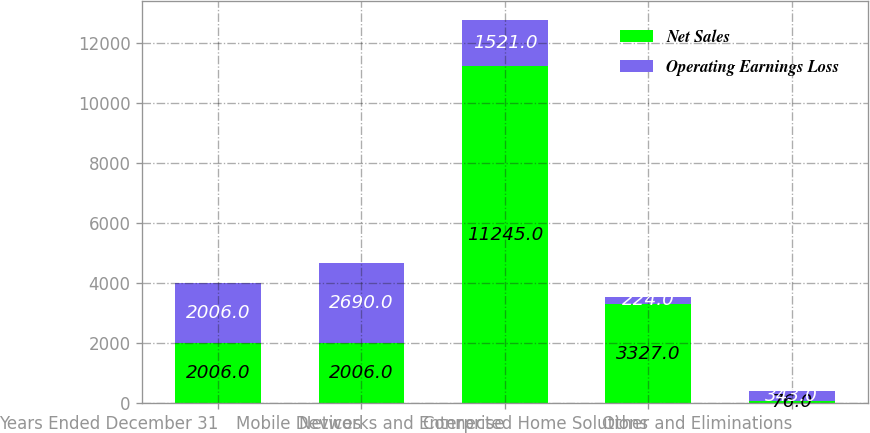<chart> <loc_0><loc_0><loc_500><loc_500><stacked_bar_chart><ecel><fcel>Years Ended December 31<fcel>Mobile Devices<fcel>Networks and Enterprise<fcel>Connected Home Solutions<fcel>Other and Eliminations<nl><fcel>Net Sales<fcel>2006<fcel>2006<fcel>11245<fcel>3327<fcel>76<nl><fcel>Operating Earnings Loss<fcel>2006<fcel>2690<fcel>1521<fcel>224<fcel>343<nl></chart> 